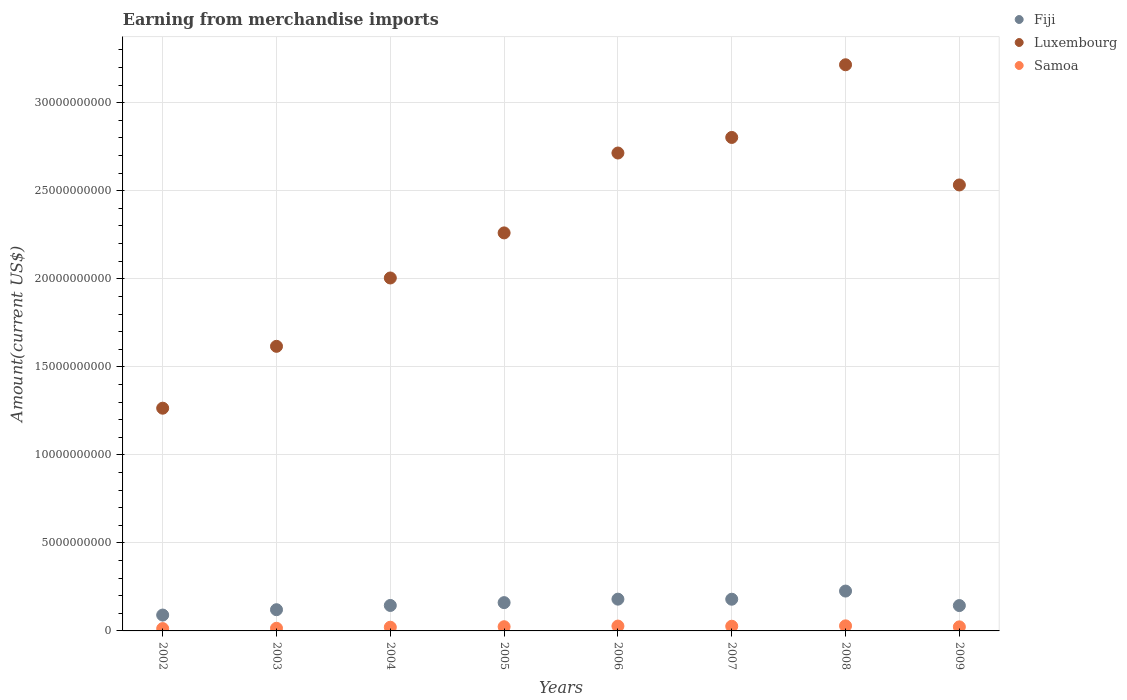What is the amount earned from merchandise imports in Samoa in 2005?
Provide a succinct answer. 2.39e+08. Across all years, what is the maximum amount earned from merchandise imports in Samoa?
Provide a short and direct response. 2.88e+08. Across all years, what is the minimum amount earned from merchandise imports in Luxembourg?
Offer a terse response. 1.27e+1. What is the total amount earned from merchandise imports in Fiji in the graph?
Offer a terse response. 1.25e+1. What is the difference between the amount earned from merchandise imports in Fiji in 2003 and that in 2004?
Your answer should be compact. -2.41e+08. What is the difference between the amount earned from merchandise imports in Samoa in 2006 and the amount earned from merchandise imports in Fiji in 2009?
Give a very brief answer. -1.16e+09. What is the average amount earned from merchandise imports in Fiji per year?
Provide a succinct answer. 1.56e+09. In the year 2006, what is the difference between the amount earned from merchandise imports in Luxembourg and amount earned from merchandise imports in Samoa?
Keep it short and to the point. 2.69e+1. What is the ratio of the amount earned from merchandise imports in Fiji in 2002 to that in 2006?
Offer a very short reply. 0.5. Is the amount earned from merchandise imports in Luxembourg in 2002 less than that in 2007?
Offer a terse response. Yes. What is the difference between the highest and the second highest amount earned from merchandise imports in Luxembourg?
Your answer should be compact. 4.13e+09. What is the difference between the highest and the lowest amount earned from merchandise imports in Luxembourg?
Give a very brief answer. 1.95e+1. Is the amount earned from merchandise imports in Samoa strictly less than the amount earned from merchandise imports in Luxembourg over the years?
Provide a short and direct response. Yes. How many dotlines are there?
Make the answer very short. 3. How many years are there in the graph?
Ensure brevity in your answer.  8. What is the difference between two consecutive major ticks on the Y-axis?
Offer a very short reply. 5.00e+09. Are the values on the major ticks of Y-axis written in scientific E-notation?
Provide a short and direct response. No. Does the graph contain grids?
Provide a short and direct response. Yes. How many legend labels are there?
Your answer should be compact. 3. What is the title of the graph?
Offer a terse response. Earning from merchandise imports. Does "Heavily indebted poor countries" appear as one of the legend labels in the graph?
Provide a short and direct response. No. What is the label or title of the Y-axis?
Offer a terse response. Amount(current US$). What is the Amount(current US$) of Fiji in 2002?
Keep it short and to the point. 9.01e+08. What is the Amount(current US$) of Luxembourg in 2002?
Your answer should be compact. 1.27e+1. What is the Amount(current US$) in Samoa in 2002?
Provide a short and direct response. 1.32e+08. What is the Amount(current US$) of Fiji in 2003?
Your answer should be very brief. 1.20e+09. What is the Amount(current US$) in Luxembourg in 2003?
Offer a very short reply. 1.62e+1. What is the Amount(current US$) of Samoa in 2003?
Offer a terse response. 1.50e+08. What is the Amount(current US$) in Fiji in 2004?
Offer a very short reply. 1.45e+09. What is the Amount(current US$) of Luxembourg in 2004?
Offer a terse response. 2.00e+1. What is the Amount(current US$) of Samoa in 2004?
Provide a succinct answer. 2.10e+08. What is the Amount(current US$) of Fiji in 2005?
Your answer should be very brief. 1.61e+09. What is the Amount(current US$) in Luxembourg in 2005?
Make the answer very short. 2.26e+1. What is the Amount(current US$) in Samoa in 2005?
Provide a short and direct response. 2.39e+08. What is the Amount(current US$) in Fiji in 2006?
Offer a terse response. 1.80e+09. What is the Amount(current US$) in Luxembourg in 2006?
Make the answer very short. 2.71e+1. What is the Amount(current US$) in Samoa in 2006?
Keep it short and to the point. 2.75e+08. What is the Amount(current US$) of Fiji in 2007?
Offer a terse response. 1.80e+09. What is the Amount(current US$) of Luxembourg in 2007?
Provide a short and direct response. 2.80e+1. What is the Amount(current US$) of Samoa in 2007?
Ensure brevity in your answer.  2.66e+08. What is the Amount(current US$) of Fiji in 2008?
Your answer should be very brief. 2.26e+09. What is the Amount(current US$) in Luxembourg in 2008?
Offer a very short reply. 3.22e+1. What is the Amount(current US$) of Samoa in 2008?
Provide a short and direct response. 2.88e+08. What is the Amount(current US$) of Fiji in 2009?
Keep it short and to the point. 1.44e+09. What is the Amount(current US$) in Luxembourg in 2009?
Your response must be concise. 2.53e+1. What is the Amount(current US$) of Samoa in 2009?
Your response must be concise. 2.31e+08. Across all years, what is the maximum Amount(current US$) in Fiji?
Keep it short and to the point. 2.26e+09. Across all years, what is the maximum Amount(current US$) in Luxembourg?
Keep it short and to the point. 3.22e+1. Across all years, what is the maximum Amount(current US$) of Samoa?
Provide a succinct answer. 2.88e+08. Across all years, what is the minimum Amount(current US$) in Fiji?
Your answer should be very brief. 9.01e+08. Across all years, what is the minimum Amount(current US$) of Luxembourg?
Keep it short and to the point. 1.27e+1. Across all years, what is the minimum Amount(current US$) in Samoa?
Give a very brief answer. 1.32e+08. What is the total Amount(current US$) of Fiji in the graph?
Your response must be concise. 1.25e+1. What is the total Amount(current US$) of Luxembourg in the graph?
Keep it short and to the point. 1.84e+11. What is the total Amount(current US$) of Samoa in the graph?
Provide a short and direct response. 1.79e+09. What is the difference between the Amount(current US$) in Fiji in 2002 and that in 2003?
Give a very brief answer. -3.04e+08. What is the difference between the Amount(current US$) in Luxembourg in 2002 and that in 2003?
Your response must be concise. -3.51e+09. What is the difference between the Amount(current US$) in Samoa in 2002 and that in 2003?
Make the answer very short. -1.81e+07. What is the difference between the Amount(current US$) of Fiji in 2002 and that in 2004?
Offer a very short reply. -5.45e+08. What is the difference between the Amount(current US$) of Luxembourg in 2002 and that in 2004?
Your response must be concise. -7.40e+09. What is the difference between the Amount(current US$) in Samoa in 2002 and that in 2004?
Offer a very short reply. -7.75e+07. What is the difference between the Amount(current US$) in Fiji in 2002 and that in 2005?
Your answer should be compact. -7.06e+08. What is the difference between the Amount(current US$) in Luxembourg in 2002 and that in 2005?
Make the answer very short. -9.96e+09. What is the difference between the Amount(current US$) of Samoa in 2002 and that in 2005?
Your response must be concise. -1.06e+08. What is the difference between the Amount(current US$) in Fiji in 2002 and that in 2006?
Make the answer very short. -9.03e+08. What is the difference between the Amount(current US$) in Luxembourg in 2002 and that in 2006?
Ensure brevity in your answer.  -1.45e+1. What is the difference between the Amount(current US$) of Samoa in 2002 and that in 2006?
Provide a succinct answer. -1.43e+08. What is the difference between the Amount(current US$) in Fiji in 2002 and that in 2007?
Provide a succinct answer. -8.99e+08. What is the difference between the Amount(current US$) of Luxembourg in 2002 and that in 2007?
Your answer should be compact. -1.54e+1. What is the difference between the Amount(current US$) of Samoa in 2002 and that in 2007?
Your response must be concise. -1.33e+08. What is the difference between the Amount(current US$) in Fiji in 2002 and that in 2008?
Provide a short and direct response. -1.36e+09. What is the difference between the Amount(current US$) of Luxembourg in 2002 and that in 2008?
Give a very brief answer. -1.95e+1. What is the difference between the Amount(current US$) in Samoa in 2002 and that in 2008?
Your response must be concise. -1.56e+08. What is the difference between the Amount(current US$) of Fiji in 2002 and that in 2009?
Provide a short and direct response. -5.39e+08. What is the difference between the Amount(current US$) in Luxembourg in 2002 and that in 2009?
Provide a succinct answer. -1.27e+1. What is the difference between the Amount(current US$) in Samoa in 2002 and that in 2009?
Provide a succinct answer. -9.82e+07. What is the difference between the Amount(current US$) in Fiji in 2003 and that in 2004?
Give a very brief answer. -2.41e+08. What is the difference between the Amount(current US$) of Luxembourg in 2003 and that in 2004?
Give a very brief answer. -3.88e+09. What is the difference between the Amount(current US$) in Samoa in 2003 and that in 2004?
Provide a succinct answer. -5.94e+07. What is the difference between the Amount(current US$) of Fiji in 2003 and that in 2005?
Your answer should be compact. -4.02e+08. What is the difference between the Amount(current US$) in Luxembourg in 2003 and that in 2005?
Provide a succinct answer. -6.44e+09. What is the difference between the Amount(current US$) of Samoa in 2003 and that in 2005?
Ensure brevity in your answer.  -8.82e+07. What is the difference between the Amount(current US$) in Fiji in 2003 and that in 2006?
Offer a very short reply. -5.99e+08. What is the difference between the Amount(current US$) in Luxembourg in 2003 and that in 2006?
Give a very brief answer. -1.10e+1. What is the difference between the Amount(current US$) in Samoa in 2003 and that in 2006?
Offer a very short reply. -1.25e+08. What is the difference between the Amount(current US$) in Fiji in 2003 and that in 2007?
Make the answer very short. -5.95e+08. What is the difference between the Amount(current US$) of Luxembourg in 2003 and that in 2007?
Keep it short and to the point. -1.19e+1. What is the difference between the Amount(current US$) in Samoa in 2003 and that in 2007?
Your response must be concise. -1.15e+08. What is the difference between the Amount(current US$) of Fiji in 2003 and that in 2008?
Make the answer very short. -1.06e+09. What is the difference between the Amount(current US$) in Luxembourg in 2003 and that in 2008?
Provide a succinct answer. -1.60e+1. What is the difference between the Amount(current US$) in Samoa in 2003 and that in 2008?
Offer a very short reply. -1.37e+08. What is the difference between the Amount(current US$) in Fiji in 2003 and that in 2009?
Provide a short and direct response. -2.35e+08. What is the difference between the Amount(current US$) in Luxembourg in 2003 and that in 2009?
Your answer should be very brief. -9.17e+09. What is the difference between the Amount(current US$) of Samoa in 2003 and that in 2009?
Ensure brevity in your answer.  -8.01e+07. What is the difference between the Amount(current US$) of Fiji in 2004 and that in 2005?
Your response must be concise. -1.61e+08. What is the difference between the Amount(current US$) of Luxembourg in 2004 and that in 2005?
Ensure brevity in your answer.  -2.56e+09. What is the difference between the Amount(current US$) of Samoa in 2004 and that in 2005?
Provide a short and direct response. -2.88e+07. What is the difference between the Amount(current US$) in Fiji in 2004 and that in 2006?
Keep it short and to the point. -3.58e+08. What is the difference between the Amount(current US$) in Luxembourg in 2004 and that in 2006?
Keep it short and to the point. -7.10e+09. What is the difference between the Amount(current US$) in Samoa in 2004 and that in 2006?
Offer a very short reply. -6.53e+07. What is the difference between the Amount(current US$) in Fiji in 2004 and that in 2007?
Your response must be concise. -3.54e+08. What is the difference between the Amount(current US$) in Luxembourg in 2004 and that in 2007?
Make the answer very short. -7.98e+09. What is the difference between the Amount(current US$) in Samoa in 2004 and that in 2007?
Provide a succinct answer. -5.58e+07. What is the difference between the Amount(current US$) in Fiji in 2004 and that in 2008?
Your response must be concise. -8.18e+08. What is the difference between the Amount(current US$) of Luxembourg in 2004 and that in 2008?
Keep it short and to the point. -1.21e+1. What is the difference between the Amount(current US$) of Samoa in 2004 and that in 2008?
Offer a very short reply. -7.81e+07. What is the difference between the Amount(current US$) in Fiji in 2004 and that in 2009?
Make the answer very short. 6.24e+06. What is the difference between the Amount(current US$) in Luxembourg in 2004 and that in 2009?
Provide a succinct answer. -5.28e+09. What is the difference between the Amount(current US$) of Samoa in 2004 and that in 2009?
Offer a terse response. -2.07e+07. What is the difference between the Amount(current US$) of Fiji in 2005 and that in 2006?
Offer a very short reply. -1.97e+08. What is the difference between the Amount(current US$) of Luxembourg in 2005 and that in 2006?
Give a very brief answer. -4.54e+09. What is the difference between the Amount(current US$) of Samoa in 2005 and that in 2006?
Keep it short and to the point. -3.65e+07. What is the difference between the Amount(current US$) in Fiji in 2005 and that in 2007?
Ensure brevity in your answer.  -1.93e+08. What is the difference between the Amount(current US$) in Luxembourg in 2005 and that in 2007?
Offer a terse response. -5.42e+09. What is the difference between the Amount(current US$) of Samoa in 2005 and that in 2007?
Provide a short and direct response. -2.70e+07. What is the difference between the Amount(current US$) in Fiji in 2005 and that in 2008?
Give a very brief answer. -6.57e+08. What is the difference between the Amount(current US$) in Luxembourg in 2005 and that in 2008?
Your answer should be very brief. -9.55e+09. What is the difference between the Amount(current US$) of Samoa in 2005 and that in 2008?
Your answer should be compact. -4.93e+07. What is the difference between the Amount(current US$) in Fiji in 2005 and that in 2009?
Your response must be concise. 1.67e+08. What is the difference between the Amount(current US$) of Luxembourg in 2005 and that in 2009?
Offer a terse response. -2.72e+09. What is the difference between the Amount(current US$) of Samoa in 2005 and that in 2009?
Your answer should be compact. 8.11e+06. What is the difference between the Amount(current US$) of Fiji in 2006 and that in 2007?
Ensure brevity in your answer.  3.76e+06. What is the difference between the Amount(current US$) in Luxembourg in 2006 and that in 2007?
Your answer should be very brief. -8.84e+08. What is the difference between the Amount(current US$) in Samoa in 2006 and that in 2007?
Provide a short and direct response. 9.49e+06. What is the difference between the Amount(current US$) in Fiji in 2006 and that in 2008?
Your answer should be compact. -4.60e+08. What is the difference between the Amount(current US$) of Luxembourg in 2006 and that in 2008?
Offer a terse response. -5.01e+09. What is the difference between the Amount(current US$) of Samoa in 2006 and that in 2008?
Your answer should be very brief. -1.28e+07. What is the difference between the Amount(current US$) of Fiji in 2006 and that in 2009?
Keep it short and to the point. 3.64e+08. What is the difference between the Amount(current US$) in Luxembourg in 2006 and that in 2009?
Make the answer very short. 1.81e+09. What is the difference between the Amount(current US$) of Samoa in 2006 and that in 2009?
Provide a succinct answer. 4.46e+07. What is the difference between the Amount(current US$) in Fiji in 2007 and that in 2008?
Ensure brevity in your answer.  -4.63e+08. What is the difference between the Amount(current US$) of Luxembourg in 2007 and that in 2008?
Ensure brevity in your answer.  -4.13e+09. What is the difference between the Amount(current US$) of Samoa in 2007 and that in 2008?
Provide a succinct answer. -2.23e+07. What is the difference between the Amount(current US$) in Fiji in 2007 and that in 2009?
Your answer should be compact. 3.61e+08. What is the difference between the Amount(current US$) in Luxembourg in 2007 and that in 2009?
Offer a terse response. 2.70e+09. What is the difference between the Amount(current US$) of Samoa in 2007 and that in 2009?
Give a very brief answer. 3.51e+07. What is the difference between the Amount(current US$) of Fiji in 2008 and that in 2009?
Keep it short and to the point. 8.24e+08. What is the difference between the Amount(current US$) in Luxembourg in 2008 and that in 2009?
Offer a terse response. 6.83e+09. What is the difference between the Amount(current US$) in Samoa in 2008 and that in 2009?
Ensure brevity in your answer.  5.74e+07. What is the difference between the Amount(current US$) in Fiji in 2002 and the Amount(current US$) in Luxembourg in 2003?
Provide a short and direct response. -1.53e+1. What is the difference between the Amount(current US$) of Fiji in 2002 and the Amount(current US$) of Samoa in 2003?
Ensure brevity in your answer.  7.51e+08. What is the difference between the Amount(current US$) of Luxembourg in 2002 and the Amount(current US$) of Samoa in 2003?
Ensure brevity in your answer.  1.25e+1. What is the difference between the Amount(current US$) of Fiji in 2002 and the Amount(current US$) of Luxembourg in 2004?
Offer a terse response. -1.91e+1. What is the difference between the Amount(current US$) of Fiji in 2002 and the Amount(current US$) of Samoa in 2004?
Give a very brief answer. 6.91e+08. What is the difference between the Amount(current US$) in Luxembourg in 2002 and the Amount(current US$) in Samoa in 2004?
Offer a terse response. 1.24e+1. What is the difference between the Amount(current US$) in Fiji in 2002 and the Amount(current US$) in Luxembourg in 2005?
Your answer should be compact. -2.17e+1. What is the difference between the Amount(current US$) of Fiji in 2002 and the Amount(current US$) of Samoa in 2005?
Offer a very short reply. 6.62e+08. What is the difference between the Amount(current US$) of Luxembourg in 2002 and the Amount(current US$) of Samoa in 2005?
Offer a very short reply. 1.24e+1. What is the difference between the Amount(current US$) of Fiji in 2002 and the Amount(current US$) of Luxembourg in 2006?
Keep it short and to the point. -2.62e+1. What is the difference between the Amount(current US$) of Fiji in 2002 and the Amount(current US$) of Samoa in 2006?
Provide a short and direct response. 6.26e+08. What is the difference between the Amount(current US$) of Luxembourg in 2002 and the Amount(current US$) of Samoa in 2006?
Ensure brevity in your answer.  1.24e+1. What is the difference between the Amount(current US$) in Fiji in 2002 and the Amount(current US$) in Luxembourg in 2007?
Provide a short and direct response. -2.71e+1. What is the difference between the Amount(current US$) in Fiji in 2002 and the Amount(current US$) in Samoa in 2007?
Keep it short and to the point. 6.35e+08. What is the difference between the Amount(current US$) in Luxembourg in 2002 and the Amount(current US$) in Samoa in 2007?
Your answer should be very brief. 1.24e+1. What is the difference between the Amount(current US$) in Fiji in 2002 and the Amount(current US$) in Luxembourg in 2008?
Give a very brief answer. -3.13e+1. What is the difference between the Amount(current US$) in Fiji in 2002 and the Amount(current US$) in Samoa in 2008?
Offer a very short reply. 6.13e+08. What is the difference between the Amount(current US$) in Luxembourg in 2002 and the Amount(current US$) in Samoa in 2008?
Offer a terse response. 1.24e+1. What is the difference between the Amount(current US$) in Fiji in 2002 and the Amount(current US$) in Luxembourg in 2009?
Ensure brevity in your answer.  -2.44e+1. What is the difference between the Amount(current US$) in Fiji in 2002 and the Amount(current US$) in Samoa in 2009?
Ensure brevity in your answer.  6.70e+08. What is the difference between the Amount(current US$) in Luxembourg in 2002 and the Amount(current US$) in Samoa in 2009?
Provide a succinct answer. 1.24e+1. What is the difference between the Amount(current US$) in Fiji in 2003 and the Amount(current US$) in Luxembourg in 2004?
Provide a short and direct response. -1.88e+1. What is the difference between the Amount(current US$) of Fiji in 2003 and the Amount(current US$) of Samoa in 2004?
Offer a terse response. 9.95e+08. What is the difference between the Amount(current US$) in Luxembourg in 2003 and the Amount(current US$) in Samoa in 2004?
Give a very brief answer. 1.60e+1. What is the difference between the Amount(current US$) of Fiji in 2003 and the Amount(current US$) of Luxembourg in 2005?
Make the answer very short. -2.14e+1. What is the difference between the Amount(current US$) in Fiji in 2003 and the Amount(current US$) in Samoa in 2005?
Your response must be concise. 9.66e+08. What is the difference between the Amount(current US$) in Luxembourg in 2003 and the Amount(current US$) in Samoa in 2005?
Your answer should be compact. 1.59e+1. What is the difference between the Amount(current US$) of Fiji in 2003 and the Amount(current US$) of Luxembourg in 2006?
Make the answer very short. -2.59e+1. What is the difference between the Amount(current US$) of Fiji in 2003 and the Amount(current US$) of Samoa in 2006?
Provide a succinct answer. 9.30e+08. What is the difference between the Amount(current US$) of Luxembourg in 2003 and the Amount(current US$) of Samoa in 2006?
Keep it short and to the point. 1.59e+1. What is the difference between the Amount(current US$) in Fiji in 2003 and the Amount(current US$) in Luxembourg in 2007?
Make the answer very short. -2.68e+1. What is the difference between the Amount(current US$) of Fiji in 2003 and the Amount(current US$) of Samoa in 2007?
Your response must be concise. 9.39e+08. What is the difference between the Amount(current US$) in Luxembourg in 2003 and the Amount(current US$) in Samoa in 2007?
Your response must be concise. 1.59e+1. What is the difference between the Amount(current US$) in Fiji in 2003 and the Amount(current US$) in Luxembourg in 2008?
Make the answer very short. -3.10e+1. What is the difference between the Amount(current US$) in Fiji in 2003 and the Amount(current US$) in Samoa in 2008?
Your response must be concise. 9.17e+08. What is the difference between the Amount(current US$) in Luxembourg in 2003 and the Amount(current US$) in Samoa in 2008?
Make the answer very short. 1.59e+1. What is the difference between the Amount(current US$) in Fiji in 2003 and the Amount(current US$) in Luxembourg in 2009?
Your answer should be very brief. -2.41e+1. What is the difference between the Amount(current US$) in Fiji in 2003 and the Amount(current US$) in Samoa in 2009?
Make the answer very short. 9.74e+08. What is the difference between the Amount(current US$) in Luxembourg in 2003 and the Amount(current US$) in Samoa in 2009?
Ensure brevity in your answer.  1.59e+1. What is the difference between the Amount(current US$) of Fiji in 2004 and the Amount(current US$) of Luxembourg in 2005?
Provide a succinct answer. -2.12e+1. What is the difference between the Amount(current US$) in Fiji in 2004 and the Amount(current US$) in Samoa in 2005?
Your response must be concise. 1.21e+09. What is the difference between the Amount(current US$) of Luxembourg in 2004 and the Amount(current US$) of Samoa in 2005?
Your response must be concise. 1.98e+1. What is the difference between the Amount(current US$) of Fiji in 2004 and the Amount(current US$) of Luxembourg in 2006?
Your answer should be very brief. -2.57e+1. What is the difference between the Amount(current US$) in Fiji in 2004 and the Amount(current US$) in Samoa in 2006?
Offer a terse response. 1.17e+09. What is the difference between the Amount(current US$) of Luxembourg in 2004 and the Amount(current US$) of Samoa in 2006?
Your answer should be very brief. 1.98e+1. What is the difference between the Amount(current US$) in Fiji in 2004 and the Amount(current US$) in Luxembourg in 2007?
Keep it short and to the point. -2.66e+1. What is the difference between the Amount(current US$) in Fiji in 2004 and the Amount(current US$) in Samoa in 2007?
Offer a terse response. 1.18e+09. What is the difference between the Amount(current US$) in Luxembourg in 2004 and the Amount(current US$) in Samoa in 2007?
Make the answer very short. 1.98e+1. What is the difference between the Amount(current US$) of Fiji in 2004 and the Amount(current US$) of Luxembourg in 2008?
Ensure brevity in your answer.  -3.07e+1. What is the difference between the Amount(current US$) in Fiji in 2004 and the Amount(current US$) in Samoa in 2008?
Provide a succinct answer. 1.16e+09. What is the difference between the Amount(current US$) in Luxembourg in 2004 and the Amount(current US$) in Samoa in 2008?
Ensure brevity in your answer.  1.98e+1. What is the difference between the Amount(current US$) in Fiji in 2004 and the Amount(current US$) in Luxembourg in 2009?
Keep it short and to the point. -2.39e+1. What is the difference between the Amount(current US$) of Fiji in 2004 and the Amount(current US$) of Samoa in 2009?
Keep it short and to the point. 1.22e+09. What is the difference between the Amount(current US$) of Luxembourg in 2004 and the Amount(current US$) of Samoa in 2009?
Ensure brevity in your answer.  1.98e+1. What is the difference between the Amount(current US$) of Fiji in 2005 and the Amount(current US$) of Luxembourg in 2006?
Your answer should be compact. -2.55e+1. What is the difference between the Amount(current US$) in Fiji in 2005 and the Amount(current US$) in Samoa in 2006?
Your answer should be compact. 1.33e+09. What is the difference between the Amount(current US$) in Luxembourg in 2005 and the Amount(current US$) in Samoa in 2006?
Offer a very short reply. 2.23e+1. What is the difference between the Amount(current US$) of Fiji in 2005 and the Amount(current US$) of Luxembourg in 2007?
Make the answer very short. -2.64e+1. What is the difference between the Amount(current US$) of Fiji in 2005 and the Amount(current US$) of Samoa in 2007?
Offer a very short reply. 1.34e+09. What is the difference between the Amount(current US$) in Luxembourg in 2005 and the Amount(current US$) in Samoa in 2007?
Offer a very short reply. 2.23e+1. What is the difference between the Amount(current US$) of Fiji in 2005 and the Amount(current US$) of Luxembourg in 2008?
Provide a succinct answer. -3.05e+1. What is the difference between the Amount(current US$) in Fiji in 2005 and the Amount(current US$) in Samoa in 2008?
Your response must be concise. 1.32e+09. What is the difference between the Amount(current US$) in Luxembourg in 2005 and the Amount(current US$) in Samoa in 2008?
Keep it short and to the point. 2.23e+1. What is the difference between the Amount(current US$) of Fiji in 2005 and the Amount(current US$) of Luxembourg in 2009?
Ensure brevity in your answer.  -2.37e+1. What is the difference between the Amount(current US$) of Fiji in 2005 and the Amount(current US$) of Samoa in 2009?
Give a very brief answer. 1.38e+09. What is the difference between the Amount(current US$) of Luxembourg in 2005 and the Amount(current US$) of Samoa in 2009?
Your response must be concise. 2.24e+1. What is the difference between the Amount(current US$) of Fiji in 2006 and the Amount(current US$) of Luxembourg in 2007?
Give a very brief answer. -2.62e+1. What is the difference between the Amount(current US$) of Fiji in 2006 and the Amount(current US$) of Samoa in 2007?
Offer a terse response. 1.54e+09. What is the difference between the Amount(current US$) in Luxembourg in 2006 and the Amount(current US$) in Samoa in 2007?
Keep it short and to the point. 2.69e+1. What is the difference between the Amount(current US$) in Fiji in 2006 and the Amount(current US$) in Luxembourg in 2008?
Give a very brief answer. -3.04e+1. What is the difference between the Amount(current US$) of Fiji in 2006 and the Amount(current US$) of Samoa in 2008?
Your answer should be very brief. 1.52e+09. What is the difference between the Amount(current US$) in Luxembourg in 2006 and the Amount(current US$) in Samoa in 2008?
Offer a terse response. 2.69e+1. What is the difference between the Amount(current US$) of Fiji in 2006 and the Amount(current US$) of Luxembourg in 2009?
Give a very brief answer. -2.35e+1. What is the difference between the Amount(current US$) of Fiji in 2006 and the Amount(current US$) of Samoa in 2009?
Ensure brevity in your answer.  1.57e+09. What is the difference between the Amount(current US$) of Luxembourg in 2006 and the Amount(current US$) of Samoa in 2009?
Provide a succinct answer. 2.69e+1. What is the difference between the Amount(current US$) of Fiji in 2007 and the Amount(current US$) of Luxembourg in 2008?
Your answer should be compact. -3.04e+1. What is the difference between the Amount(current US$) in Fiji in 2007 and the Amount(current US$) in Samoa in 2008?
Your answer should be very brief. 1.51e+09. What is the difference between the Amount(current US$) in Luxembourg in 2007 and the Amount(current US$) in Samoa in 2008?
Offer a terse response. 2.77e+1. What is the difference between the Amount(current US$) in Fiji in 2007 and the Amount(current US$) in Luxembourg in 2009?
Your answer should be very brief. -2.35e+1. What is the difference between the Amount(current US$) in Fiji in 2007 and the Amount(current US$) in Samoa in 2009?
Provide a short and direct response. 1.57e+09. What is the difference between the Amount(current US$) in Luxembourg in 2007 and the Amount(current US$) in Samoa in 2009?
Provide a succinct answer. 2.78e+1. What is the difference between the Amount(current US$) in Fiji in 2008 and the Amount(current US$) in Luxembourg in 2009?
Provide a succinct answer. -2.31e+1. What is the difference between the Amount(current US$) of Fiji in 2008 and the Amount(current US$) of Samoa in 2009?
Offer a terse response. 2.03e+09. What is the difference between the Amount(current US$) of Luxembourg in 2008 and the Amount(current US$) of Samoa in 2009?
Make the answer very short. 3.19e+1. What is the average Amount(current US$) in Fiji per year?
Offer a terse response. 1.56e+09. What is the average Amount(current US$) in Luxembourg per year?
Keep it short and to the point. 2.30e+1. What is the average Amount(current US$) of Samoa per year?
Offer a very short reply. 2.24e+08. In the year 2002, what is the difference between the Amount(current US$) in Fiji and Amount(current US$) in Luxembourg?
Offer a very short reply. -1.17e+1. In the year 2002, what is the difference between the Amount(current US$) of Fiji and Amount(current US$) of Samoa?
Give a very brief answer. 7.69e+08. In the year 2002, what is the difference between the Amount(current US$) in Luxembourg and Amount(current US$) in Samoa?
Your response must be concise. 1.25e+1. In the year 2003, what is the difference between the Amount(current US$) in Fiji and Amount(current US$) in Luxembourg?
Give a very brief answer. -1.50e+1. In the year 2003, what is the difference between the Amount(current US$) in Fiji and Amount(current US$) in Samoa?
Make the answer very short. 1.05e+09. In the year 2003, what is the difference between the Amount(current US$) of Luxembourg and Amount(current US$) of Samoa?
Your answer should be very brief. 1.60e+1. In the year 2004, what is the difference between the Amount(current US$) of Fiji and Amount(current US$) of Luxembourg?
Your answer should be compact. -1.86e+1. In the year 2004, what is the difference between the Amount(current US$) of Fiji and Amount(current US$) of Samoa?
Provide a short and direct response. 1.24e+09. In the year 2004, what is the difference between the Amount(current US$) in Luxembourg and Amount(current US$) in Samoa?
Your answer should be compact. 1.98e+1. In the year 2005, what is the difference between the Amount(current US$) in Fiji and Amount(current US$) in Luxembourg?
Give a very brief answer. -2.10e+1. In the year 2005, what is the difference between the Amount(current US$) in Fiji and Amount(current US$) in Samoa?
Your answer should be compact. 1.37e+09. In the year 2005, what is the difference between the Amount(current US$) in Luxembourg and Amount(current US$) in Samoa?
Your answer should be compact. 2.24e+1. In the year 2006, what is the difference between the Amount(current US$) of Fiji and Amount(current US$) of Luxembourg?
Your response must be concise. -2.53e+1. In the year 2006, what is the difference between the Amount(current US$) of Fiji and Amount(current US$) of Samoa?
Give a very brief answer. 1.53e+09. In the year 2006, what is the difference between the Amount(current US$) of Luxembourg and Amount(current US$) of Samoa?
Provide a succinct answer. 2.69e+1. In the year 2007, what is the difference between the Amount(current US$) in Fiji and Amount(current US$) in Luxembourg?
Your answer should be compact. -2.62e+1. In the year 2007, what is the difference between the Amount(current US$) of Fiji and Amount(current US$) of Samoa?
Offer a very short reply. 1.53e+09. In the year 2007, what is the difference between the Amount(current US$) of Luxembourg and Amount(current US$) of Samoa?
Offer a terse response. 2.78e+1. In the year 2008, what is the difference between the Amount(current US$) of Fiji and Amount(current US$) of Luxembourg?
Provide a succinct answer. -2.99e+1. In the year 2008, what is the difference between the Amount(current US$) of Fiji and Amount(current US$) of Samoa?
Your response must be concise. 1.98e+09. In the year 2008, what is the difference between the Amount(current US$) in Luxembourg and Amount(current US$) in Samoa?
Provide a succinct answer. 3.19e+1. In the year 2009, what is the difference between the Amount(current US$) in Fiji and Amount(current US$) in Luxembourg?
Provide a succinct answer. -2.39e+1. In the year 2009, what is the difference between the Amount(current US$) in Fiji and Amount(current US$) in Samoa?
Your answer should be very brief. 1.21e+09. In the year 2009, what is the difference between the Amount(current US$) of Luxembourg and Amount(current US$) of Samoa?
Make the answer very short. 2.51e+1. What is the ratio of the Amount(current US$) in Fiji in 2002 to that in 2003?
Offer a very short reply. 0.75. What is the ratio of the Amount(current US$) in Luxembourg in 2002 to that in 2003?
Provide a succinct answer. 0.78. What is the ratio of the Amount(current US$) in Samoa in 2002 to that in 2003?
Ensure brevity in your answer.  0.88. What is the ratio of the Amount(current US$) in Fiji in 2002 to that in 2004?
Keep it short and to the point. 0.62. What is the ratio of the Amount(current US$) in Luxembourg in 2002 to that in 2004?
Your answer should be compact. 0.63. What is the ratio of the Amount(current US$) in Samoa in 2002 to that in 2004?
Provide a short and direct response. 0.63. What is the ratio of the Amount(current US$) of Fiji in 2002 to that in 2005?
Give a very brief answer. 0.56. What is the ratio of the Amount(current US$) in Luxembourg in 2002 to that in 2005?
Make the answer very short. 0.56. What is the ratio of the Amount(current US$) in Samoa in 2002 to that in 2005?
Make the answer very short. 0.55. What is the ratio of the Amount(current US$) of Fiji in 2002 to that in 2006?
Provide a succinct answer. 0.5. What is the ratio of the Amount(current US$) of Luxembourg in 2002 to that in 2006?
Offer a terse response. 0.47. What is the ratio of the Amount(current US$) of Samoa in 2002 to that in 2006?
Your answer should be very brief. 0.48. What is the ratio of the Amount(current US$) in Fiji in 2002 to that in 2007?
Make the answer very short. 0.5. What is the ratio of the Amount(current US$) in Luxembourg in 2002 to that in 2007?
Your answer should be compact. 0.45. What is the ratio of the Amount(current US$) in Samoa in 2002 to that in 2007?
Offer a very short reply. 0.5. What is the ratio of the Amount(current US$) in Fiji in 2002 to that in 2008?
Your response must be concise. 0.4. What is the ratio of the Amount(current US$) in Luxembourg in 2002 to that in 2008?
Offer a terse response. 0.39. What is the ratio of the Amount(current US$) in Samoa in 2002 to that in 2008?
Make the answer very short. 0.46. What is the ratio of the Amount(current US$) in Fiji in 2002 to that in 2009?
Provide a succinct answer. 0.63. What is the ratio of the Amount(current US$) in Luxembourg in 2002 to that in 2009?
Your response must be concise. 0.5. What is the ratio of the Amount(current US$) in Samoa in 2002 to that in 2009?
Provide a short and direct response. 0.57. What is the ratio of the Amount(current US$) of Luxembourg in 2003 to that in 2004?
Ensure brevity in your answer.  0.81. What is the ratio of the Amount(current US$) in Samoa in 2003 to that in 2004?
Your answer should be compact. 0.72. What is the ratio of the Amount(current US$) of Fiji in 2003 to that in 2005?
Your response must be concise. 0.75. What is the ratio of the Amount(current US$) in Luxembourg in 2003 to that in 2005?
Provide a short and direct response. 0.71. What is the ratio of the Amount(current US$) of Samoa in 2003 to that in 2005?
Ensure brevity in your answer.  0.63. What is the ratio of the Amount(current US$) in Fiji in 2003 to that in 2006?
Your response must be concise. 0.67. What is the ratio of the Amount(current US$) of Luxembourg in 2003 to that in 2006?
Make the answer very short. 0.6. What is the ratio of the Amount(current US$) of Samoa in 2003 to that in 2006?
Give a very brief answer. 0.55. What is the ratio of the Amount(current US$) in Fiji in 2003 to that in 2007?
Provide a succinct answer. 0.67. What is the ratio of the Amount(current US$) in Luxembourg in 2003 to that in 2007?
Your answer should be compact. 0.58. What is the ratio of the Amount(current US$) of Samoa in 2003 to that in 2007?
Your answer should be compact. 0.57. What is the ratio of the Amount(current US$) of Fiji in 2003 to that in 2008?
Offer a terse response. 0.53. What is the ratio of the Amount(current US$) in Luxembourg in 2003 to that in 2008?
Give a very brief answer. 0.5. What is the ratio of the Amount(current US$) in Samoa in 2003 to that in 2008?
Keep it short and to the point. 0.52. What is the ratio of the Amount(current US$) of Fiji in 2003 to that in 2009?
Your response must be concise. 0.84. What is the ratio of the Amount(current US$) in Luxembourg in 2003 to that in 2009?
Offer a terse response. 0.64. What is the ratio of the Amount(current US$) in Samoa in 2003 to that in 2009?
Your answer should be very brief. 0.65. What is the ratio of the Amount(current US$) of Fiji in 2004 to that in 2005?
Ensure brevity in your answer.  0.9. What is the ratio of the Amount(current US$) in Luxembourg in 2004 to that in 2005?
Ensure brevity in your answer.  0.89. What is the ratio of the Amount(current US$) of Samoa in 2004 to that in 2005?
Offer a terse response. 0.88. What is the ratio of the Amount(current US$) in Fiji in 2004 to that in 2006?
Ensure brevity in your answer.  0.8. What is the ratio of the Amount(current US$) of Luxembourg in 2004 to that in 2006?
Offer a terse response. 0.74. What is the ratio of the Amount(current US$) in Samoa in 2004 to that in 2006?
Your answer should be very brief. 0.76. What is the ratio of the Amount(current US$) in Fiji in 2004 to that in 2007?
Provide a short and direct response. 0.8. What is the ratio of the Amount(current US$) in Luxembourg in 2004 to that in 2007?
Give a very brief answer. 0.72. What is the ratio of the Amount(current US$) in Samoa in 2004 to that in 2007?
Provide a succinct answer. 0.79. What is the ratio of the Amount(current US$) of Fiji in 2004 to that in 2008?
Make the answer very short. 0.64. What is the ratio of the Amount(current US$) of Luxembourg in 2004 to that in 2008?
Give a very brief answer. 0.62. What is the ratio of the Amount(current US$) in Samoa in 2004 to that in 2008?
Your answer should be very brief. 0.73. What is the ratio of the Amount(current US$) of Luxembourg in 2004 to that in 2009?
Keep it short and to the point. 0.79. What is the ratio of the Amount(current US$) of Samoa in 2004 to that in 2009?
Provide a short and direct response. 0.91. What is the ratio of the Amount(current US$) of Fiji in 2005 to that in 2006?
Your answer should be very brief. 0.89. What is the ratio of the Amount(current US$) in Luxembourg in 2005 to that in 2006?
Your response must be concise. 0.83. What is the ratio of the Amount(current US$) of Samoa in 2005 to that in 2006?
Your answer should be compact. 0.87. What is the ratio of the Amount(current US$) of Fiji in 2005 to that in 2007?
Keep it short and to the point. 0.89. What is the ratio of the Amount(current US$) of Luxembourg in 2005 to that in 2007?
Offer a terse response. 0.81. What is the ratio of the Amount(current US$) in Samoa in 2005 to that in 2007?
Your response must be concise. 0.9. What is the ratio of the Amount(current US$) in Fiji in 2005 to that in 2008?
Provide a succinct answer. 0.71. What is the ratio of the Amount(current US$) in Luxembourg in 2005 to that in 2008?
Offer a very short reply. 0.7. What is the ratio of the Amount(current US$) in Samoa in 2005 to that in 2008?
Provide a succinct answer. 0.83. What is the ratio of the Amount(current US$) in Fiji in 2005 to that in 2009?
Give a very brief answer. 1.12. What is the ratio of the Amount(current US$) in Luxembourg in 2005 to that in 2009?
Provide a short and direct response. 0.89. What is the ratio of the Amount(current US$) of Samoa in 2005 to that in 2009?
Provide a succinct answer. 1.04. What is the ratio of the Amount(current US$) in Luxembourg in 2006 to that in 2007?
Ensure brevity in your answer.  0.97. What is the ratio of the Amount(current US$) of Samoa in 2006 to that in 2007?
Offer a terse response. 1.04. What is the ratio of the Amount(current US$) in Fiji in 2006 to that in 2008?
Your response must be concise. 0.8. What is the ratio of the Amount(current US$) in Luxembourg in 2006 to that in 2008?
Provide a short and direct response. 0.84. What is the ratio of the Amount(current US$) in Samoa in 2006 to that in 2008?
Provide a succinct answer. 0.96. What is the ratio of the Amount(current US$) of Fiji in 2006 to that in 2009?
Offer a very short reply. 1.25. What is the ratio of the Amount(current US$) of Luxembourg in 2006 to that in 2009?
Give a very brief answer. 1.07. What is the ratio of the Amount(current US$) in Samoa in 2006 to that in 2009?
Your response must be concise. 1.19. What is the ratio of the Amount(current US$) in Fiji in 2007 to that in 2008?
Offer a very short reply. 0.8. What is the ratio of the Amount(current US$) of Luxembourg in 2007 to that in 2008?
Offer a very short reply. 0.87. What is the ratio of the Amount(current US$) of Samoa in 2007 to that in 2008?
Offer a terse response. 0.92. What is the ratio of the Amount(current US$) of Fiji in 2007 to that in 2009?
Your answer should be compact. 1.25. What is the ratio of the Amount(current US$) of Luxembourg in 2007 to that in 2009?
Your answer should be very brief. 1.11. What is the ratio of the Amount(current US$) in Samoa in 2007 to that in 2009?
Keep it short and to the point. 1.15. What is the ratio of the Amount(current US$) in Fiji in 2008 to that in 2009?
Your answer should be very brief. 1.57. What is the ratio of the Amount(current US$) in Luxembourg in 2008 to that in 2009?
Make the answer very short. 1.27. What is the ratio of the Amount(current US$) in Samoa in 2008 to that in 2009?
Ensure brevity in your answer.  1.25. What is the difference between the highest and the second highest Amount(current US$) in Fiji?
Provide a short and direct response. 4.60e+08. What is the difference between the highest and the second highest Amount(current US$) in Luxembourg?
Provide a short and direct response. 4.13e+09. What is the difference between the highest and the second highest Amount(current US$) in Samoa?
Offer a very short reply. 1.28e+07. What is the difference between the highest and the lowest Amount(current US$) of Fiji?
Make the answer very short. 1.36e+09. What is the difference between the highest and the lowest Amount(current US$) of Luxembourg?
Make the answer very short. 1.95e+1. What is the difference between the highest and the lowest Amount(current US$) in Samoa?
Your answer should be compact. 1.56e+08. 